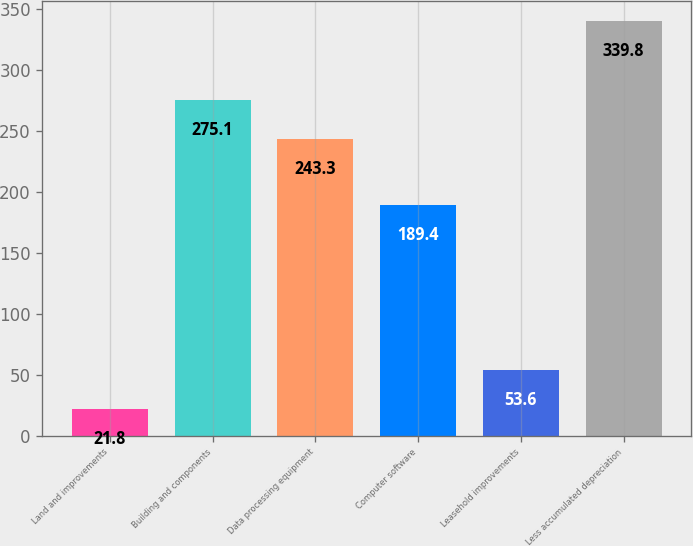Convert chart. <chart><loc_0><loc_0><loc_500><loc_500><bar_chart><fcel>Land and improvements<fcel>Building and components<fcel>Data processing equipment<fcel>Computer software<fcel>Leasehold improvements<fcel>Less accumulated depreciation<nl><fcel>21.8<fcel>275.1<fcel>243.3<fcel>189.4<fcel>53.6<fcel>339.8<nl></chart> 